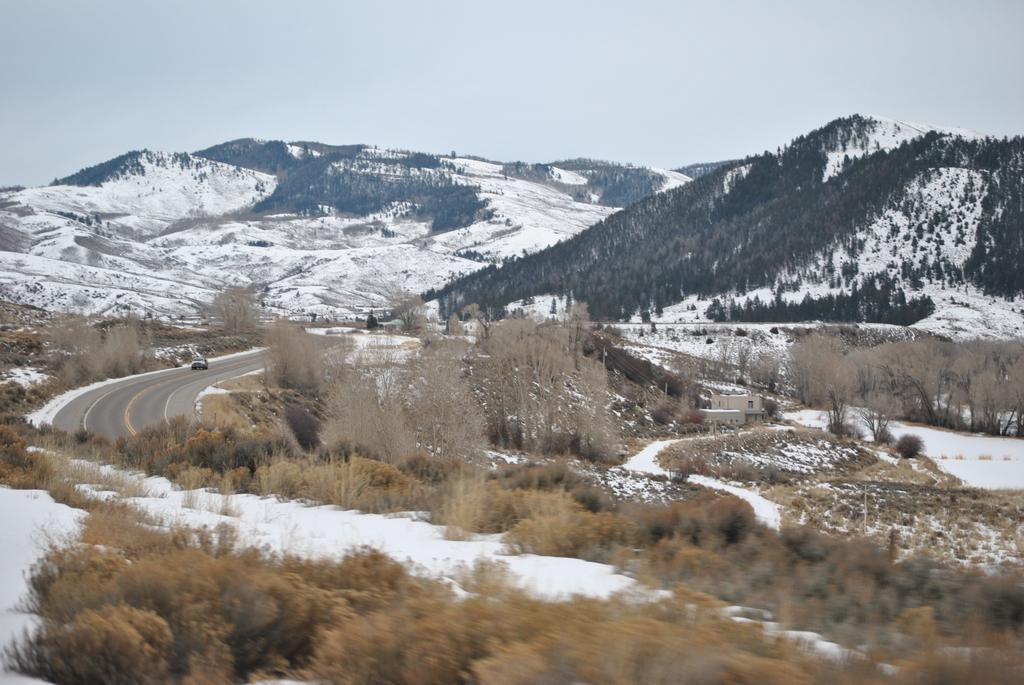What is happening in the image involving a vehicle? There is a vehicle moving on the road in the image. What type of natural features can be seen in the image? Trees and mountains are present in the image. What is the weather like in the image? Snow is present in the image, indicating a cold or snowy environment. What is visible in the background of the image? The sky is visible in the background of the image. What type of argument is taking place between the toys in the image? There are no toys present in the image, and therefore no argument can be observed. 